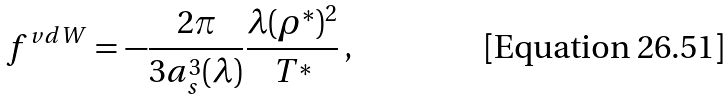Convert formula to latex. <formula><loc_0><loc_0><loc_500><loc_500>f ^ { v d W } = - \frac { 2 \pi } { 3 a _ { s } ^ { 3 } ( \lambda ) } \frac { \lambda ( \rho ^ { * } ) ^ { 2 } } { T ^ { * } } \, ,</formula> 